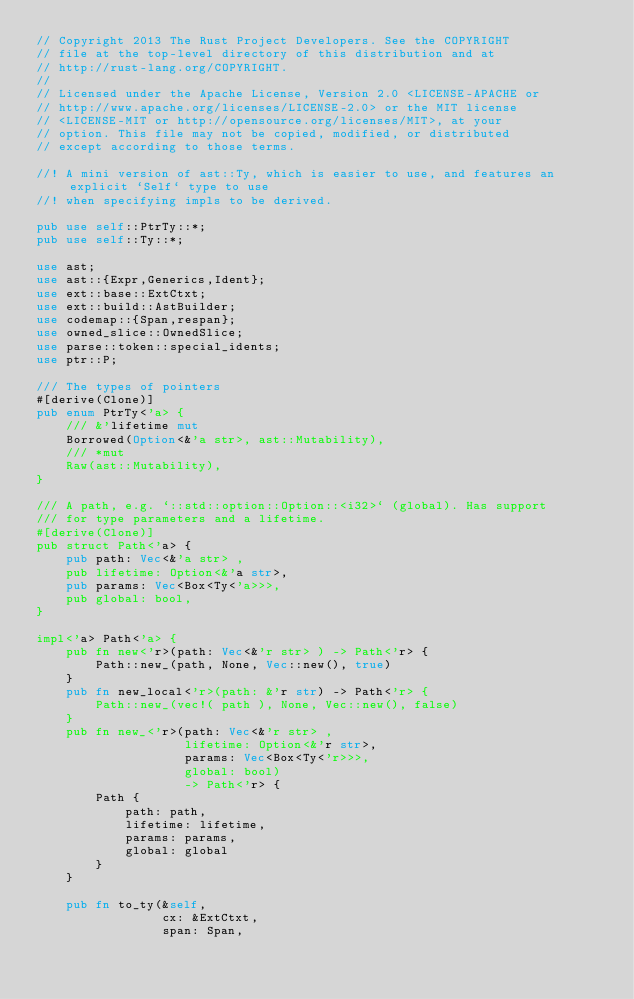<code> <loc_0><loc_0><loc_500><loc_500><_Rust_>// Copyright 2013 The Rust Project Developers. See the COPYRIGHT
// file at the top-level directory of this distribution and at
// http://rust-lang.org/COPYRIGHT.
//
// Licensed under the Apache License, Version 2.0 <LICENSE-APACHE or
// http://www.apache.org/licenses/LICENSE-2.0> or the MIT license
// <LICENSE-MIT or http://opensource.org/licenses/MIT>, at your
// option. This file may not be copied, modified, or distributed
// except according to those terms.

//! A mini version of ast::Ty, which is easier to use, and features an explicit `Self` type to use
//! when specifying impls to be derived.

pub use self::PtrTy::*;
pub use self::Ty::*;

use ast;
use ast::{Expr,Generics,Ident};
use ext::base::ExtCtxt;
use ext::build::AstBuilder;
use codemap::{Span,respan};
use owned_slice::OwnedSlice;
use parse::token::special_idents;
use ptr::P;

/// The types of pointers
#[derive(Clone)]
pub enum PtrTy<'a> {
    /// &'lifetime mut
    Borrowed(Option<&'a str>, ast::Mutability),
    /// *mut
    Raw(ast::Mutability),
}

/// A path, e.g. `::std::option::Option::<i32>` (global). Has support
/// for type parameters and a lifetime.
#[derive(Clone)]
pub struct Path<'a> {
    pub path: Vec<&'a str> ,
    pub lifetime: Option<&'a str>,
    pub params: Vec<Box<Ty<'a>>>,
    pub global: bool,
}

impl<'a> Path<'a> {
    pub fn new<'r>(path: Vec<&'r str> ) -> Path<'r> {
        Path::new_(path, None, Vec::new(), true)
    }
    pub fn new_local<'r>(path: &'r str) -> Path<'r> {
        Path::new_(vec!( path ), None, Vec::new(), false)
    }
    pub fn new_<'r>(path: Vec<&'r str> ,
                    lifetime: Option<&'r str>,
                    params: Vec<Box<Ty<'r>>>,
                    global: bool)
                    -> Path<'r> {
        Path {
            path: path,
            lifetime: lifetime,
            params: params,
            global: global
        }
    }

    pub fn to_ty(&self,
                 cx: &ExtCtxt,
                 span: Span,</code> 